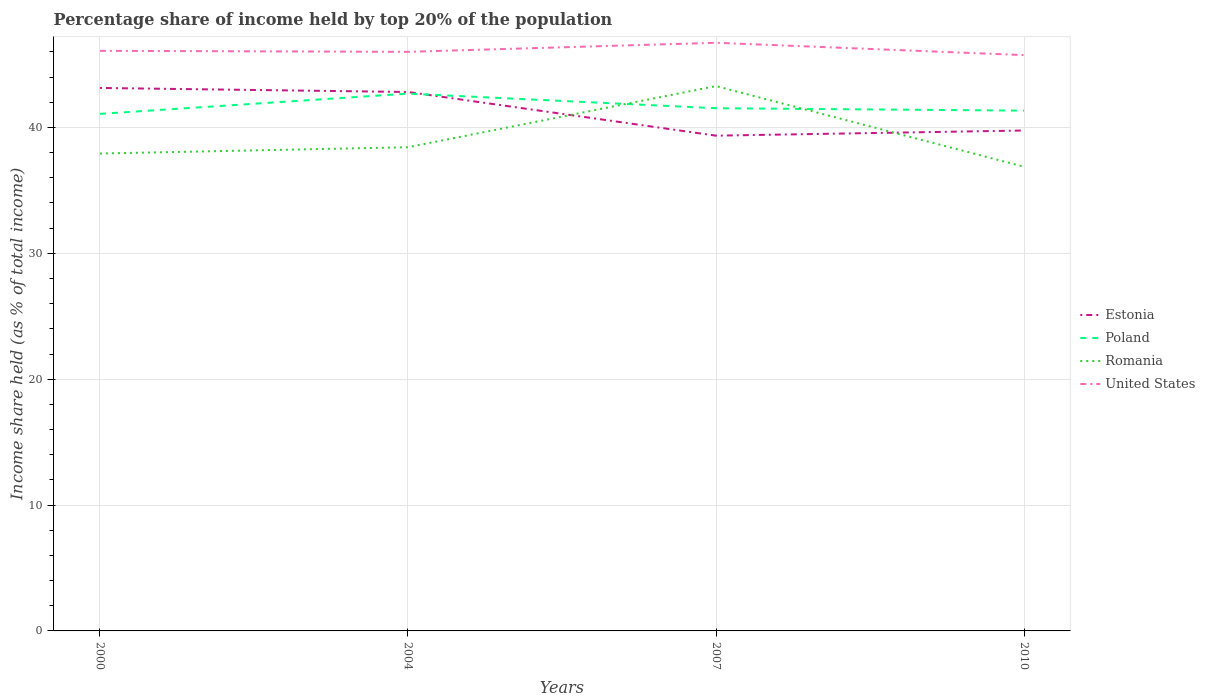Does the line corresponding to Estonia intersect with the line corresponding to United States?
Your response must be concise. No. Across all years, what is the maximum percentage share of income held by top 20% of the population in Romania?
Your answer should be compact. 36.88. In which year was the percentage share of income held by top 20% of the population in Romania maximum?
Your answer should be very brief. 2010. What is the total percentage share of income held by top 20% of the population in United States in the graph?
Give a very brief answer. 0.34. What is the difference between the highest and the second highest percentage share of income held by top 20% of the population in Estonia?
Your response must be concise. 3.79. What is the difference between the highest and the lowest percentage share of income held by top 20% of the population in United States?
Your answer should be compact. 1. How many lines are there?
Keep it short and to the point. 4. Does the graph contain grids?
Give a very brief answer. Yes. Where does the legend appear in the graph?
Your answer should be very brief. Center right. How many legend labels are there?
Your answer should be compact. 4. What is the title of the graph?
Give a very brief answer. Percentage share of income held by top 20% of the population. Does "Belgium" appear as one of the legend labels in the graph?
Give a very brief answer. No. What is the label or title of the Y-axis?
Offer a very short reply. Income share held (as % of total income). What is the Income share held (as % of total income) in Estonia in 2000?
Offer a very short reply. 43.14. What is the Income share held (as % of total income) of Poland in 2000?
Give a very brief answer. 41.08. What is the Income share held (as % of total income) of Romania in 2000?
Keep it short and to the point. 37.93. What is the Income share held (as % of total income) in United States in 2000?
Keep it short and to the point. 46.09. What is the Income share held (as % of total income) of Estonia in 2004?
Make the answer very short. 42.82. What is the Income share held (as % of total income) of Poland in 2004?
Make the answer very short. 42.69. What is the Income share held (as % of total income) of Romania in 2004?
Ensure brevity in your answer.  38.43. What is the Income share held (as % of total income) of United States in 2004?
Offer a very short reply. 46.01. What is the Income share held (as % of total income) of Estonia in 2007?
Make the answer very short. 39.35. What is the Income share held (as % of total income) in Poland in 2007?
Your response must be concise. 41.53. What is the Income share held (as % of total income) in Romania in 2007?
Offer a terse response. 43.29. What is the Income share held (as % of total income) of United States in 2007?
Your response must be concise. 46.73. What is the Income share held (as % of total income) of Estonia in 2010?
Keep it short and to the point. 39.76. What is the Income share held (as % of total income) of Poland in 2010?
Your response must be concise. 41.34. What is the Income share held (as % of total income) of Romania in 2010?
Your response must be concise. 36.88. What is the Income share held (as % of total income) in United States in 2010?
Keep it short and to the point. 45.75. Across all years, what is the maximum Income share held (as % of total income) of Estonia?
Keep it short and to the point. 43.14. Across all years, what is the maximum Income share held (as % of total income) in Poland?
Your answer should be compact. 42.69. Across all years, what is the maximum Income share held (as % of total income) of Romania?
Provide a succinct answer. 43.29. Across all years, what is the maximum Income share held (as % of total income) of United States?
Ensure brevity in your answer.  46.73. Across all years, what is the minimum Income share held (as % of total income) of Estonia?
Give a very brief answer. 39.35. Across all years, what is the minimum Income share held (as % of total income) in Poland?
Offer a very short reply. 41.08. Across all years, what is the minimum Income share held (as % of total income) of Romania?
Make the answer very short. 36.88. Across all years, what is the minimum Income share held (as % of total income) of United States?
Your response must be concise. 45.75. What is the total Income share held (as % of total income) of Estonia in the graph?
Your answer should be very brief. 165.07. What is the total Income share held (as % of total income) of Poland in the graph?
Keep it short and to the point. 166.64. What is the total Income share held (as % of total income) of Romania in the graph?
Keep it short and to the point. 156.53. What is the total Income share held (as % of total income) of United States in the graph?
Offer a terse response. 184.58. What is the difference between the Income share held (as % of total income) of Estonia in 2000 and that in 2004?
Make the answer very short. 0.32. What is the difference between the Income share held (as % of total income) in Poland in 2000 and that in 2004?
Offer a very short reply. -1.61. What is the difference between the Income share held (as % of total income) in Romania in 2000 and that in 2004?
Offer a terse response. -0.5. What is the difference between the Income share held (as % of total income) in Estonia in 2000 and that in 2007?
Ensure brevity in your answer.  3.79. What is the difference between the Income share held (as % of total income) of Poland in 2000 and that in 2007?
Provide a succinct answer. -0.45. What is the difference between the Income share held (as % of total income) of Romania in 2000 and that in 2007?
Keep it short and to the point. -5.36. What is the difference between the Income share held (as % of total income) in United States in 2000 and that in 2007?
Provide a succinct answer. -0.64. What is the difference between the Income share held (as % of total income) of Estonia in 2000 and that in 2010?
Provide a short and direct response. 3.38. What is the difference between the Income share held (as % of total income) in Poland in 2000 and that in 2010?
Make the answer very short. -0.26. What is the difference between the Income share held (as % of total income) in Romania in 2000 and that in 2010?
Provide a short and direct response. 1.05. What is the difference between the Income share held (as % of total income) in United States in 2000 and that in 2010?
Provide a short and direct response. 0.34. What is the difference between the Income share held (as % of total income) in Estonia in 2004 and that in 2007?
Ensure brevity in your answer.  3.47. What is the difference between the Income share held (as % of total income) of Poland in 2004 and that in 2007?
Give a very brief answer. 1.16. What is the difference between the Income share held (as % of total income) in Romania in 2004 and that in 2007?
Make the answer very short. -4.86. What is the difference between the Income share held (as % of total income) of United States in 2004 and that in 2007?
Your response must be concise. -0.72. What is the difference between the Income share held (as % of total income) of Estonia in 2004 and that in 2010?
Your answer should be compact. 3.06. What is the difference between the Income share held (as % of total income) in Poland in 2004 and that in 2010?
Your answer should be very brief. 1.35. What is the difference between the Income share held (as % of total income) in Romania in 2004 and that in 2010?
Your answer should be very brief. 1.55. What is the difference between the Income share held (as % of total income) of United States in 2004 and that in 2010?
Ensure brevity in your answer.  0.26. What is the difference between the Income share held (as % of total income) in Estonia in 2007 and that in 2010?
Make the answer very short. -0.41. What is the difference between the Income share held (as % of total income) in Poland in 2007 and that in 2010?
Provide a succinct answer. 0.19. What is the difference between the Income share held (as % of total income) of Romania in 2007 and that in 2010?
Keep it short and to the point. 6.41. What is the difference between the Income share held (as % of total income) of United States in 2007 and that in 2010?
Your answer should be very brief. 0.98. What is the difference between the Income share held (as % of total income) in Estonia in 2000 and the Income share held (as % of total income) in Poland in 2004?
Keep it short and to the point. 0.45. What is the difference between the Income share held (as % of total income) in Estonia in 2000 and the Income share held (as % of total income) in Romania in 2004?
Make the answer very short. 4.71. What is the difference between the Income share held (as % of total income) in Estonia in 2000 and the Income share held (as % of total income) in United States in 2004?
Offer a terse response. -2.87. What is the difference between the Income share held (as % of total income) of Poland in 2000 and the Income share held (as % of total income) of Romania in 2004?
Keep it short and to the point. 2.65. What is the difference between the Income share held (as % of total income) in Poland in 2000 and the Income share held (as % of total income) in United States in 2004?
Ensure brevity in your answer.  -4.93. What is the difference between the Income share held (as % of total income) in Romania in 2000 and the Income share held (as % of total income) in United States in 2004?
Your answer should be compact. -8.08. What is the difference between the Income share held (as % of total income) in Estonia in 2000 and the Income share held (as % of total income) in Poland in 2007?
Offer a very short reply. 1.61. What is the difference between the Income share held (as % of total income) in Estonia in 2000 and the Income share held (as % of total income) in Romania in 2007?
Give a very brief answer. -0.15. What is the difference between the Income share held (as % of total income) in Estonia in 2000 and the Income share held (as % of total income) in United States in 2007?
Provide a short and direct response. -3.59. What is the difference between the Income share held (as % of total income) of Poland in 2000 and the Income share held (as % of total income) of Romania in 2007?
Keep it short and to the point. -2.21. What is the difference between the Income share held (as % of total income) in Poland in 2000 and the Income share held (as % of total income) in United States in 2007?
Your answer should be compact. -5.65. What is the difference between the Income share held (as % of total income) in Romania in 2000 and the Income share held (as % of total income) in United States in 2007?
Offer a terse response. -8.8. What is the difference between the Income share held (as % of total income) in Estonia in 2000 and the Income share held (as % of total income) in Poland in 2010?
Keep it short and to the point. 1.8. What is the difference between the Income share held (as % of total income) of Estonia in 2000 and the Income share held (as % of total income) of Romania in 2010?
Provide a short and direct response. 6.26. What is the difference between the Income share held (as % of total income) in Estonia in 2000 and the Income share held (as % of total income) in United States in 2010?
Offer a terse response. -2.61. What is the difference between the Income share held (as % of total income) of Poland in 2000 and the Income share held (as % of total income) of United States in 2010?
Offer a very short reply. -4.67. What is the difference between the Income share held (as % of total income) of Romania in 2000 and the Income share held (as % of total income) of United States in 2010?
Your response must be concise. -7.82. What is the difference between the Income share held (as % of total income) of Estonia in 2004 and the Income share held (as % of total income) of Poland in 2007?
Your answer should be compact. 1.29. What is the difference between the Income share held (as % of total income) of Estonia in 2004 and the Income share held (as % of total income) of Romania in 2007?
Make the answer very short. -0.47. What is the difference between the Income share held (as % of total income) in Estonia in 2004 and the Income share held (as % of total income) in United States in 2007?
Provide a succinct answer. -3.91. What is the difference between the Income share held (as % of total income) of Poland in 2004 and the Income share held (as % of total income) of United States in 2007?
Your answer should be compact. -4.04. What is the difference between the Income share held (as % of total income) in Romania in 2004 and the Income share held (as % of total income) in United States in 2007?
Give a very brief answer. -8.3. What is the difference between the Income share held (as % of total income) of Estonia in 2004 and the Income share held (as % of total income) of Poland in 2010?
Keep it short and to the point. 1.48. What is the difference between the Income share held (as % of total income) of Estonia in 2004 and the Income share held (as % of total income) of Romania in 2010?
Offer a very short reply. 5.94. What is the difference between the Income share held (as % of total income) in Estonia in 2004 and the Income share held (as % of total income) in United States in 2010?
Your answer should be very brief. -2.93. What is the difference between the Income share held (as % of total income) in Poland in 2004 and the Income share held (as % of total income) in Romania in 2010?
Offer a very short reply. 5.81. What is the difference between the Income share held (as % of total income) in Poland in 2004 and the Income share held (as % of total income) in United States in 2010?
Give a very brief answer. -3.06. What is the difference between the Income share held (as % of total income) in Romania in 2004 and the Income share held (as % of total income) in United States in 2010?
Your answer should be compact. -7.32. What is the difference between the Income share held (as % of total income) in Estonia in 2007 and the Income share held (as % of total income) in Poland in 2010?
Give a very brief answer. -1.99. What is the difference between the Income share held (as % of total income) in Estonia in 2007 and the Income share held (as % of total income) in Romania in 2010?
Offer a very short reply. 2.47. What is the difference between the Income share held (as % of total income) of Poland in 2007 and the Income share held (as % of total income) of Romania in 2010?
Keep it short and to the point. 4.65. What is the difference between the Income share held (as % of total income) in Poland in 2007 and the Income share held (as % of total income) in United States in 2010?
Offer a terse response. -4.22. What is the difference between the Income share held (as % of total income) in Romania in 2007 and the Income share held (as % of total income) in United States in 2010?
Your answer should be very brief. -2.46. What is the average Income share held (as % of total income) in Estonia per year?
Provide a succinct answer. 41.27. What is the average Income share held (as % of total income) of Poland per year?
Keep it short and to the point. 41.66. What is the average Income share held (as % of total income) in Romania per year?
Your response must be concise. 39.13. What is the average Income share held (as % of total income) in United States per year?
Provide a succinct answer. 46.15. In the year 2000, what is the difference between the Income share held (as % of total income) of Estonia and Income share held (as % of total income) of Poland?
Keep it short and to the point. 2.06. In the year 2000, what is the difference between the Income share held (as % of total income) in Estonia and Income share held (as % of total income) in Romania?
Provide a short and direct response. 5.21. In the year 2000, what is the difference between the Income share held (as % of total income) in Estonia and Income share held (as % of total income) in United States?
Offer a very short reply. -2.95. In the year 2000, what is the difference between the Income share held (as % of total income) of Poland and Income share held (as % of total income) of Romania?
Offer a terse response. 3.15. In the year 2000, what is the difference between the Income share held (as % of total income) of Poland and Income share held (as % of total income) of United States?
Offer a very short reply. -5.01. In the year 2000, what is the difference between the Income share held (as % of total income) of Romania and Income share held (as % of total income) of United States?
Give a very brief answer. -8.16. In the year 2004, what is the difference between the Income share held (as % of total income) of Estonia and Income share held (as % of total income) of Poland?
Offer a terse response. 0.13. In the year 2004, what is the difference between the Income share held (as % of total income) of Estonia and Income share held (as % of total income) of Romania?
Give a very brief answer. 4.39. In the year 2004, what is the difference between the Income share held (as % of total income) in Estonia and Income share held (as % of total income) in United States?
Provide a short and direct response. -3.19. In the year 2004, what is the difference between the Income share held (as % of total income) in Poland and Income share held (as % of total income) in Romania?
Your answer should be very brief. 4.26. In the year 2004, what is the difference between the Income share held (as % of total income) of Poland and Income share held (as % of total income) of United States?
Make the answer very short. -3.32. In the year 2004, what is the difference between the Income share held (as % of total income) of Romania and Income share held (as % of total income) of United States?
Offer a very short reply. -7.58. In the year 2007, what is the difference between the Income share held (as % of total income) of Estonia and Income share held (as % of total income) of Poland?
Keep it short and to the point. -2.18. In the year 2007, what is the difference between the Income share held (as % of total income) in Estonia and Income share held (as % of total income) in Romania?
Make the answer very short. -3.94. In the year 2007, what is the difference between the Income share held (as % of total income) in Estonia and Income share held (as % of total income) in United States?
Give a very brief answer. -7.38. In the year 2007, what is the difference between the Income share held (as % of total income) of Poland and Income share held (as % of total income) of Romania?
Your response must be concise. -1.76. In the year 2007, what is the difference between the Income share held (as % of total income) of Romania and Income share held (as % of total income) of United States?
Give a very brief answer. -3.44. In the year 2010, what is the difference between the Income share held (as % of total income) of Estonia and Income share held (as % of total income) of Poland?
Offer a terse response. -1.58. In the year 2010, what is the difference between the Income share held (as % of total income) in Estonia and Income share held (as % of total income) in Romania?
Provide a succinct answer. 2.88. In the year 2010, what is the difference between the Income share held (as % of total income) of Estonia and Income share held (as % of total income) of United States?
Your response must be concise. -5.99. In the year 2010, what is the difference between the Income share held (as % of total income) in Poland and Income share held (as % of total income) in Romania?
Provide a short and direct response. 4.46. In the year 2010, what is the difference between the Income share held (as % of total income) of Poland and Income share held (as % of total income) of United States?
Your answer should be compact. -4.41. In the year 2010, what is the difference between the Income share held (as % of total income) of Romania and Income share held (as % of total income) of United States?
Offer a terse response. -8.87. What is the ratio of the Income share held (as % of total income) of Estonia in 2000 to that in 2004?
Provide a short and direct response. 1.01. What is the ratio of the Income share held (as % of total income) in Poland in 2000 to that in 2004?
Provide a short and direct response. 0.96. What is the ratio of the Income share held (as % of total income) in Estonia in 2000 to that in 2007?
Provide a succinct answer. 1.1. What is the ratio of the Income share held (as % of total income) of Poland in 2000 to that in 2007?
Make the answer very short. 0.99. What is the ratio of the Income share held (as % of total income) of Romania in 2000 to that in 2007?
Ensure brevity in your answer.  0.88. What is the ratio of the Income share held (as % of total income) of United States in 2000 to that in 2007?
Offer a very short reply. 0.99. What is the ratio of the Income share held (as % of total income) in Estonia in 2000 to that in 2010?
Give a very brief answer. 1.08. What is the ratio of the Income share held (as % of total income) in Poland in 2000 to that in 2010?
Provide a succinct answer. 0.99. What is the ratio of the Income share held (as % of total income) of Romania in 2000 to that in 2010?
Provide a short and direct response. 1.03. What is the ratio of the Income share held (as % of total income) of United States in 2000 to that in 2010?
Your response must be concise. 1.01. What is the ratio of the Income share held (as % of total income) in Estonia in 2004 to that in 2007?
Keep it short and to the point. 1.09. What is the ratio of the Income share held (as % of total income) of Poland in 2004 to that in 2007?
Keep it short and to the point. 1.03. What is the ratio of the Income share held (as % of total income) of Romania in 2004 to that in 2007?
Provide a succinct answer. 0.89. What is the ratio of the Income share held (as % of total income) of United States in 2004 to that in 2007?
Give a very brief answer. 0.98. What is the ratio of the Income share held (as % of total income) in Estonia in 2004 to that in 2010?
Offer a terse response. 1.08. What is the ratio of the Income share held (as % of total income) in Poland in 2004 to that in 2010?
Give a very brief answer. 1.03. What is the ratio of the Income share held (as % of total income) in Romania in 2004 to that in 2010?
Ensure brevity in your answer.  1.04. What is the ratio of the Income share held (as % of total income) of United States in 2004 to that in 2010?
Give a very brief answer. 1.01. What is the ratio of the Income share held (as % of total income) of Estonia in 2007 to that in 2010?
Provide a succinct answer. 0.99. What is the ratio of the Income share held (as % of total income) in Romania in 2007 to that in 2010?
Provide a short and direct response. 1.17. What is the ratio of the Income share held (as % of total income) in United States in 2007 to that in 2010?
Provide a succinct answer. 1.02. What is the difference between the highest and the second highest Income share held (as % of total income) of Estonia?
Give a very brief answer. 0.32. What is the difference between the highest and the second highest Income share held (as % of total income) in Poland?
Keep it short and to the point. 1.16. What is the difference between the highest and the second highest Income share held (as % of total income) in Romania?
Your answer should be very brief. 4.86. What is the difference between the highest and the second highest Income share held (as % of total income) of United States?
Ensure brevity in your answer.  0.64. What is the difference between the highest and the lowest Income share held (as % of total income) in Estonia?
Offer a very short reply. 3.79. What is the difference between the highest and the lowest Income share held (as % of total income) of Poland?
Offer a very short reply. 1.61. What is the difference between the highest and the lowest Income share held (as % of total income) in Romania?
Provide a short and direct response. 6.41. What is the difference between the highest and the lowest Income share held (as % of total income) in United States?
Keep it short and to the point. 0.98. 